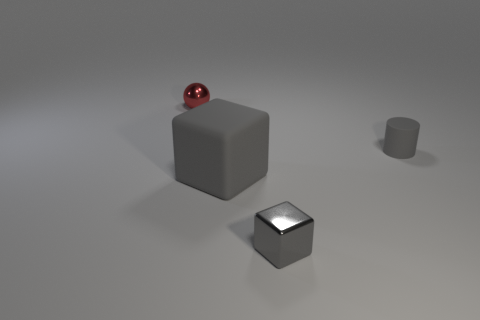Add 1 small gray blocks. How many objects exist? 5 Subtract all cylinders. How many objects are left? 3 Subtract 0 purple cylinders. How many objects are left? 4 Subtract all brown metal balls. Subtract all big gray rubber things. How many objects are left? 3 Add 1 tiny red shiny balls. How many tiny red shiny balls are left? 2 Add 1 red cylinders. How many red cylinders exist? 1 